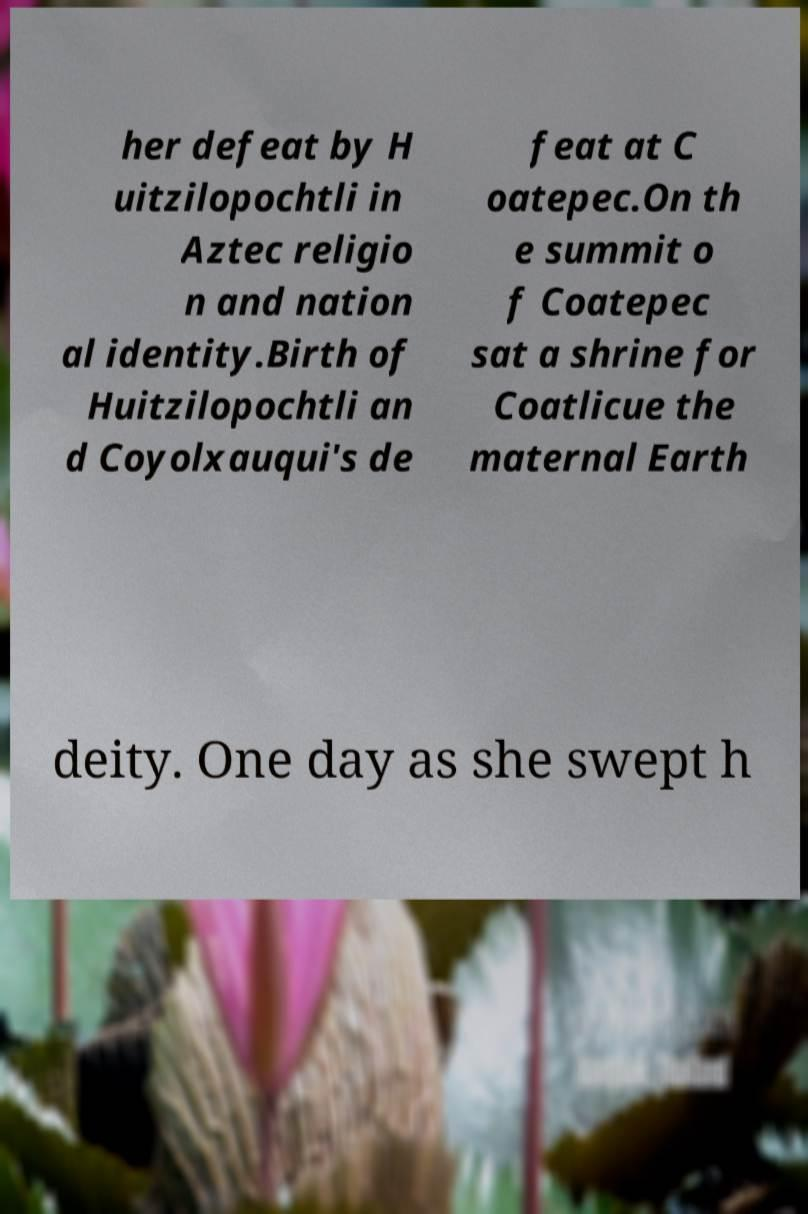Can you accurately transcribe the text from the provided image for me? her defeat by H uitzilopochtli in Aztec religio n and nation al identity.Birth of Huitzilopochtli an d Coyolxauqui's de feat at C oatepec.On th e summit o f Coatepec sat a shrine for Coatlicue the maternal Earth deity. One day as she swept h 